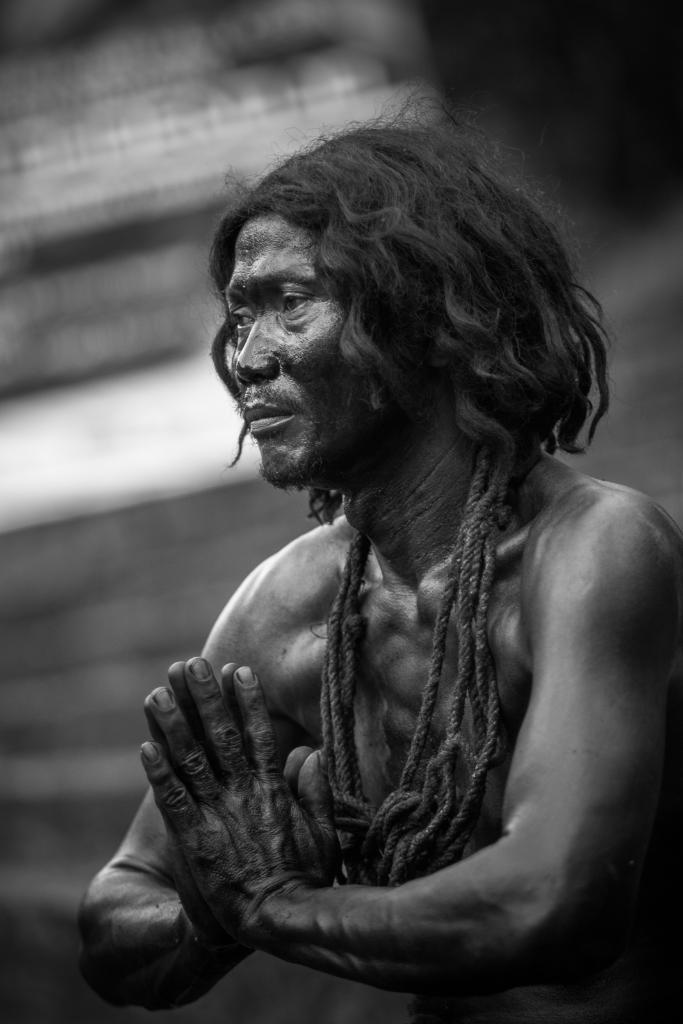What is the color scheme of the image? The image is black and white. Who is present in the image? There is a man in the image. In which direction is the man facing? The man is facing towards the left side. What is tied around the man's neck? There is a rope around the man's neck. Can you describe the background of the image? The background of the image is blurred. What type of coat is the man wearing in the image? There is no coat visible in the image; the man is wearing a rope around his neck. How many horses can be seen in the image? There are no horses present in the image. 